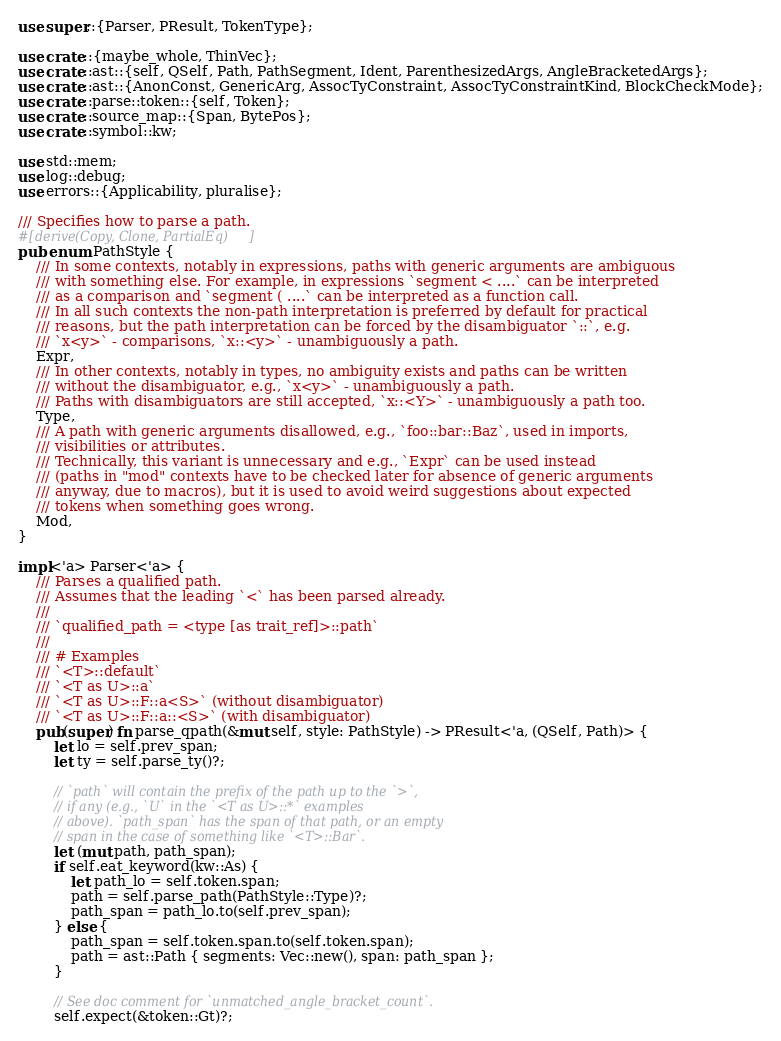<code> <loc_0><loc_0><loc_500><loc_500><_Rust_>use super::{Parser, PResult, TokenType};

use crate::{maybe_whole, ThinVec};
use crate::ast::{self, QSelf, Path, PathSegment, Ident, ParenthesizedArgs, AngleBracketedArgs};
use crate::ast::{AnonConst, GenericArg, AssocTyConstraint, AssocTyConstraintKind, BlockCheckMode};
use crate::parse::token::{self, Token};
use crate::source_map::{Span, BytePos};
use crate::symbol::kw;

use std::mem;
use log::debug;
use errors::{Applicability, pluralise};

/// Specifies how to parse a path.
#[derive(Copy, Clone, PartialEq)]
pub enum PathStyle {
    /// In some contexts, notably in expressions, paths with generic arguments are ambiguous
    /// with something else. For example, in expressions `segment < ....` can be interpreted
    /// as a comparison and `segment ( ....` can be interpreted as a function call.
    /// In all such contexts the non-path interpretation is preferred by default for practical
    /// reasons, but the path interpretation can be forced by the disambiguator `::`, e.g.
    /// `x<y>` - comparisons, `x::<y>` - unambiguously a path.
    Expr,
    /// In other contexts, notably in types, no ambiguity exists and paths can be written
    /// without the disambiguator, e.g., `x<y>` - unambiguously a path.
    /// Paths with disambiguators are still accepted, `x::<Y>` - unambiguously a path too.
    Type,
    /// A path with generic arguments disallowed, e.g., `foo::bar::Baz`, used in imports,
    /// visibilities or attributes.
    /// Technically, this variant is unnecessary and e.g., `Expr` can be used instead
    /// (paths in "mod" contexts have to be checked later for absence of generic arguments
    /// anyway, due to macros), but it is used to avoid weird suggestions about expected
    /// tokens when something goes wrong.
    Mod,
}

impl<'a> Parser<'a> {
    /// Parses a qualified path.
    /// Assumes that the leading `<` has been parsed already.
    ///
    /// `qualified_path = <type [as trait_ref]>::path`
    ///
    /// # Examples
    /// `<T>::default`
    /// `<T as U>::a`
    /// `<T as U>::F::a<S>` (without disambiguator)
    /// `<T as U>::F::a::<S>` (with disambiguator)
    pub(super) fn parse_qpath(&mut self, style: PathStyle) -> PResult<'a, (QSelf, Path)> {
        let lo = self.prev_span;
        let ty = self.parse_ty()?;

        // `path` will contain the prefix of the path up to the `>`,
        // if any (e.g., `U` in the `<T as U>::*` examples
        // above). `path_span` has the span of that path, or an empty
        // span in the case of something like `<T>::Bar`.
        let (mut path, path_span);
        if self.eat_keyword(kw::As) {
            let path_lo = self.token.span;
            path = self.parse_path(PathStyle::Type)?;
            path_span = path_lo.to(self.prev_span);
        } else {
            path_span = self.token.span.to(self.token.span);
            path = ast::Path { segments: Vec::new(), span: path_span };
        }

        // See doc comment for `unmatched_angle_bracket_count`.
        self.expect(&token::Gt)?;</code> 